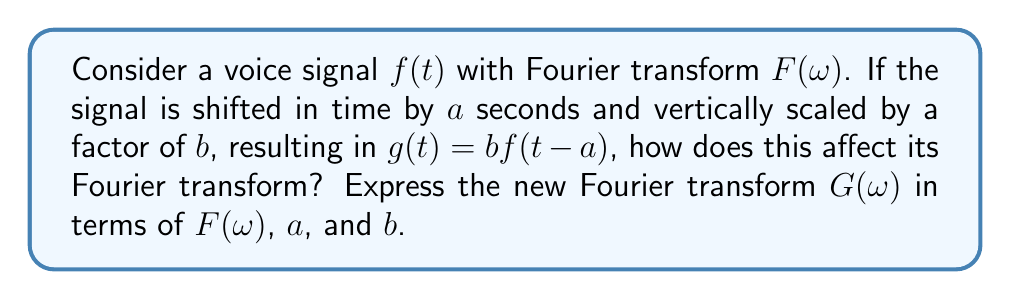Show me your answer to this math problem. To solve this problem, we'll use the properties of Fourier transforms and analyze the effects of time shifting and scaling:

1. Time shifting property:
   If $f(t)$ has a Fourier transform $F(\omega)$, then $f(t-a)$ has a Fourier transform $e^{-j\omega a}F(\omega)$.

2. Scaling property:
   If $f(t)$ has a Fourier transform $F(\omega)$, then $bf(t)$ has a Fourier transform $bF(\omega)$.

Now, let's apply these properties to our problem:

1. First, consider the time shift: $f(t-a)$ has a Fourier transform $e^{-j\omega a}F(\omega)$.

2. Then, apply the scaling factor $b$: $bf(t-a)$ has a Fourier transform $b \cdot e^{-j\omega a}F(\omega)$.

Therefore, the Fourier transform of $g(t) = bf(t-a)$ is:

$$G(\omega) = b \cdot e^{-j\omega a}F(\omega)$$

This result shows that:
- The time shift by $a$ introduces a phase shift in the frequency domain, represented by the complex exponential $e^{-j\omega a}$.
- The vertical scaling by $b$ multiplies the entire Fourier transform by $b$.

In the context of voice recognition, understanding these transformations is crucial for developing robust algorithms that can handle variations in speech timing and amplitude while maintaining accurate recognition.
Answer: $G(\omega) = b \cdot e^{-j\omega a}F(\omega)$ 